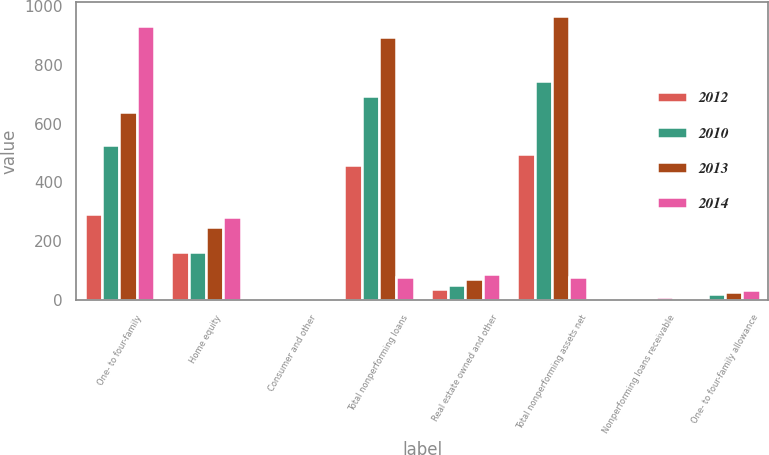Convert chart. <chart><loc_0><loc_0><loc_500><loc_500><stacked_bar_chart><ecel><fcel>One- to four-family<fcel>Home equity<fcel>Consumer and other<fcel>Total nonperforming loans<fcel>Real estate owned and other<fcel>Total nonperforming assets net<fcel>Nonperforming loans receivable<fcel>One- to four-family allowance<nl><fcel>2012<fcel>294<fcel>165<fcel>1<fcel>460<fcel>38<fcel>498<fcel>7.2<fcel>9.1<nl><fcel>2010<fcel>526<fcel>164<fcel>3<fcel>693<fcel>53<fcel>746<fcel>8.1<fcel>19.5<nl><fcel>2013<fcel>639<fcel>248<fcel>6<fcel>893<fcel>71<fcel>964<fcel>8.4<fcel>28.8<nl><fcel>2014<fcel>930<fcel>281<fcel>5<fcel>79.5<fcel>88<fcel>79.5<fcel>9.2<fcel>33.8<nl></chart> 